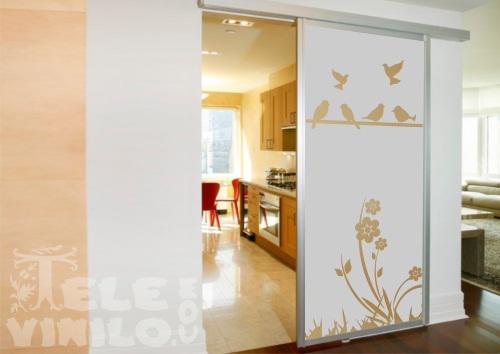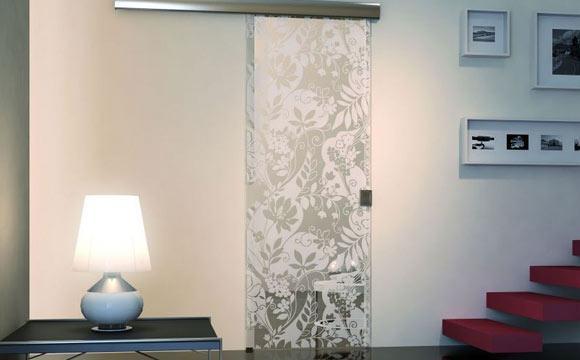The first image is the image on the left, the second image is the image on the right. Given the left and right images, does the statement "There are three sheet of glass that are decorated with art and at least one different image." hold true? Answer yes or no. No. 